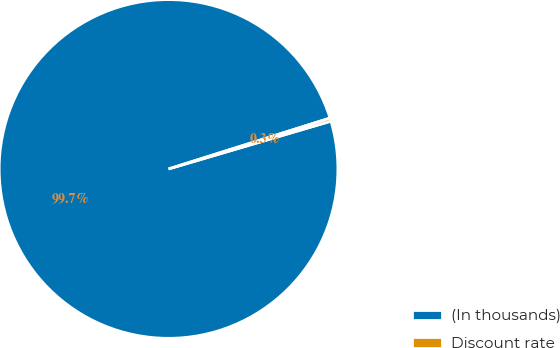Convert chart. <chart><loc_0><loc_0><loc_500><loc_500><pie_chart><fcel>(In thousands)<fcel>Discount rate<nl><fcel>99.7%<fcel>0.3%<nl></chart> 